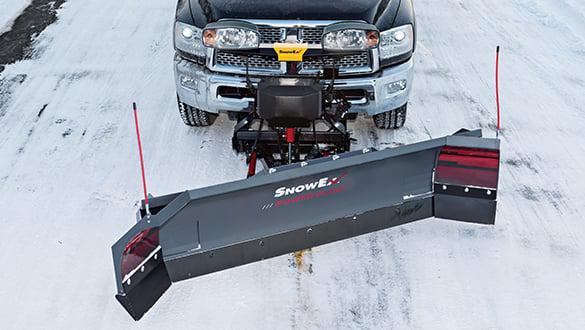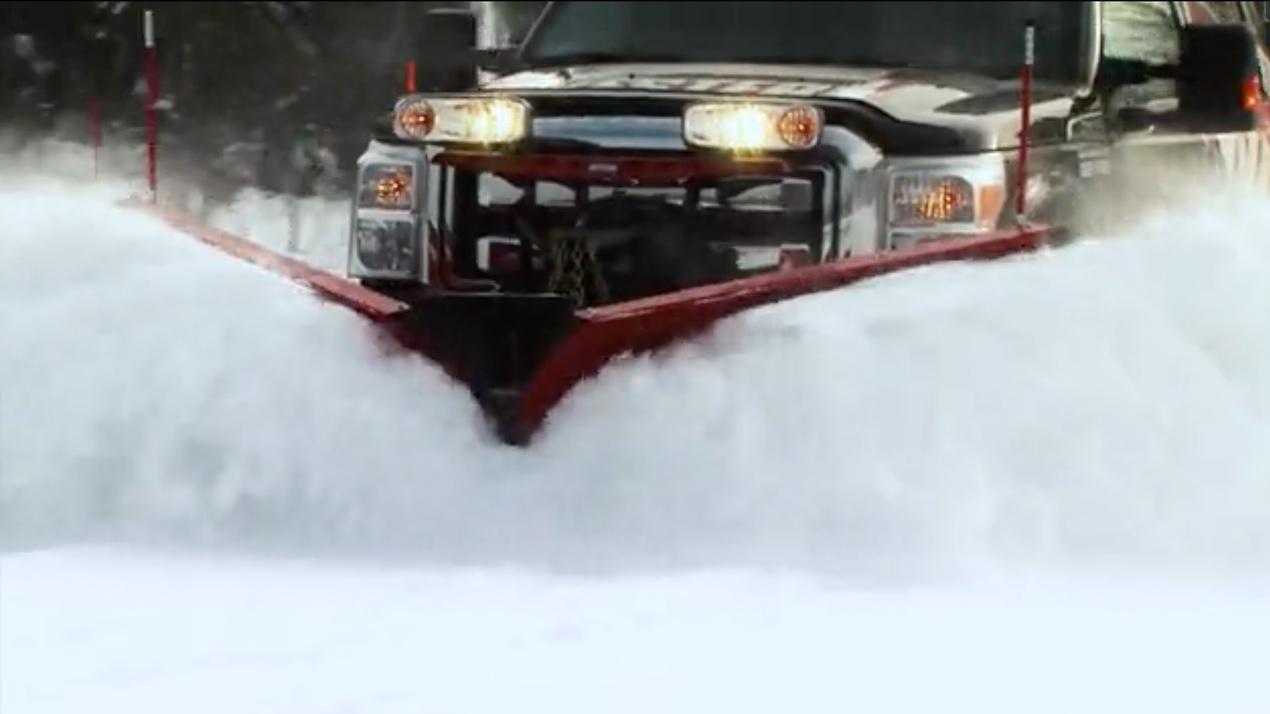The first image is the image on the left, the second image is the image on the right. Examine the images to the left and right. Is the description "A truck with yellow bulldozer panel is pushing a pile of snow." accurate? Answer yes or no. No. The first image is the image on the left, the second image is the image on the right. Considering the images on both sides, is "All of the plows in the snow are yellow." valid? Answer yes or no. No. 